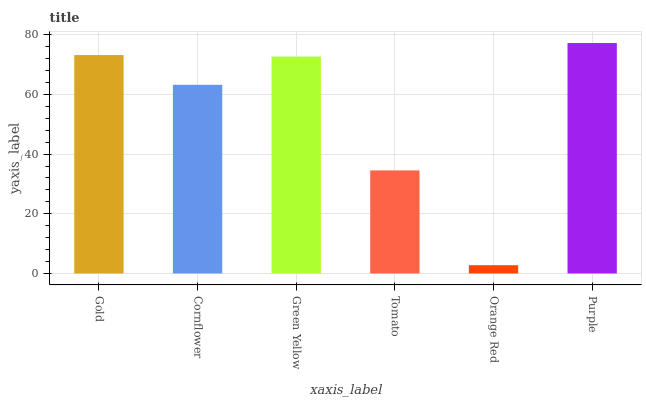Is Orange Red the minimum?
Answer yes or no. Yes. Is Purple the maximum?
Answer yes or no. Yes. Is Cornflower the minimum?
Answer yes or no. No. Is Cornflower the maximum?
Answer yes or no. No. Is Gold greater than Cornflower?
Answer yes or no. Yes. Is Cornflower less than Gold?
Answer yes or no. Yes. Is Cornflower greater than Gold?
Answer yes or no. No. Is Gold less than Cornflower?
Answer yes or no. No. Is Green Yellow the high median?
Answer yes or no. Yes. Is Cornflower the low median?
Answer yes or no. Yes. Is Gold the high median?
Answer yes or no. No. Is Orange Red the low median?
Answer yes or no. No. 